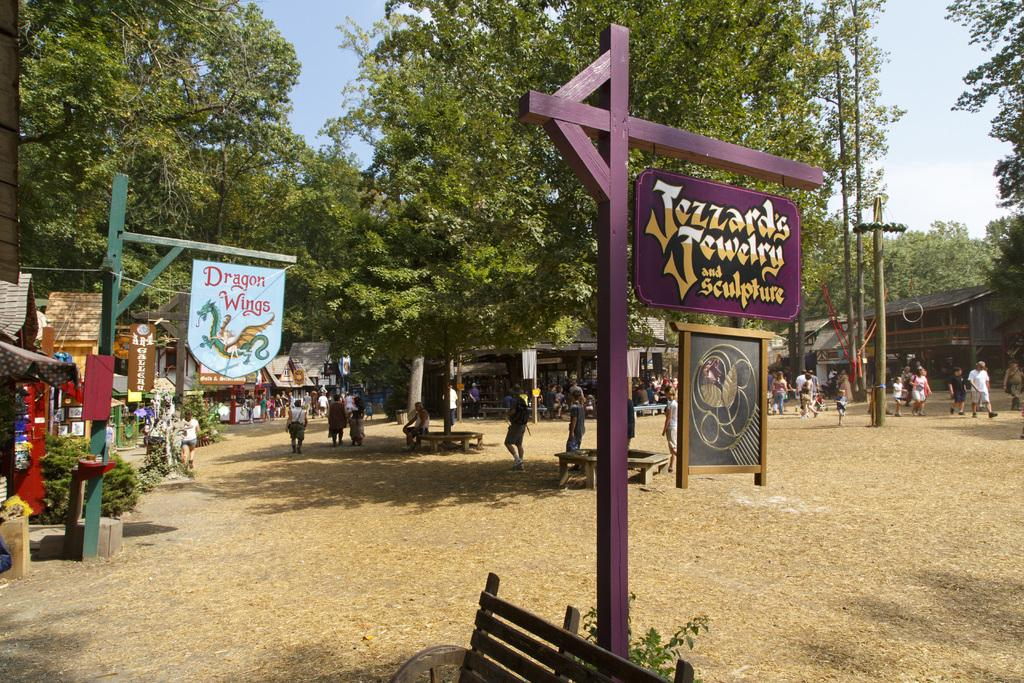What objects are present in the image that have poles attached to them? There are boards with poles in the image. What type of seating can be seen in the image? There are benches in the image. What are the people in the image doing? There is a group of people standing in the image. What type of structures are present in the image for selling goods or services? There are stalls in the image. What type of vegetation is present in the image? There are plants and trees in the image. What is visible in the background of the image? The sky is visible in the background of the image. What type of thread is being used by the trees in the image? There is no thread present in the image; the trees are not using any thread. How does the group of people express their anger in the image? There is no indication of anger in the image; the group of people is simply standing. 